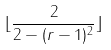Convert formula to latex. <formula><loc_0><loc_0><loc_500><loc_500>\lfloor \frac { 2 } { 2 - ( r - 1 ) ^ { 2 } } \rfloor</formula> 